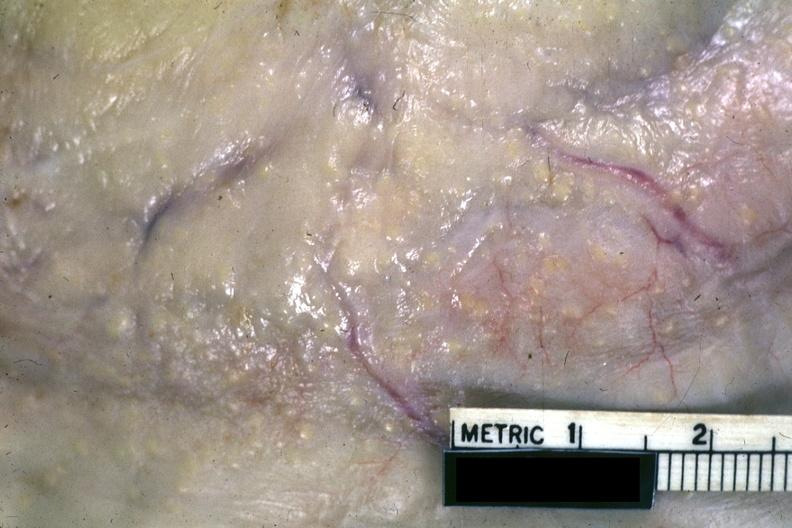where is this area in the body?
Answer the question using a single word or phrase. Abdomen 